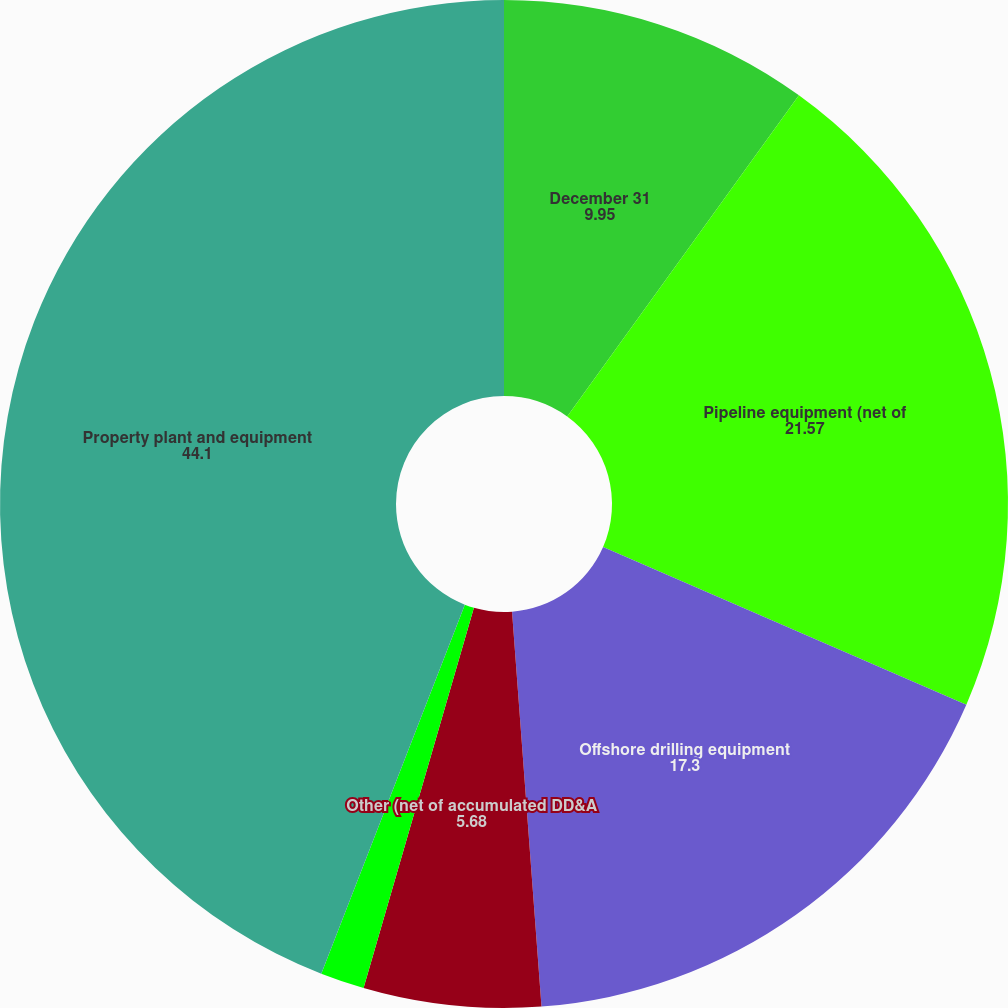Convert chart. <chart><loc_0><loc_0><loc_500><loc_500><pie_chart><fcel>December 31<fcel>Pipeline equipment (net of<fcel>Offshore drilling equipment<fcel>Other (net of accumulated DD&A<fcel>Construction in process<fcel>Property plant and equipment<nl><fcel>9.95%<fcel>21.57%<fcel>17.3%<fcel>5.68%<fcel>1.41%<fcel>44.1%<nl></chart> 